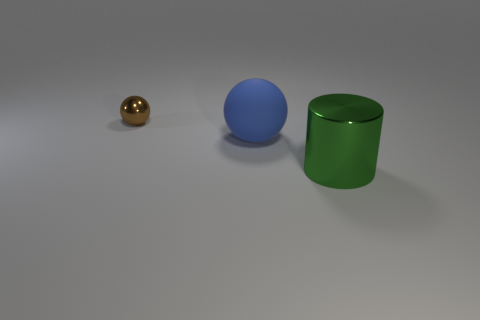Add 3 big cylinders. How many objects exist? 6 Subtract all balls. How many objects are left? 1 Subtract 0 purple spheres. How many objects are left? 3 Subtract all blue rubber objects. Subtract all large cylinders. How many objects are left? 1 Add 2 small objects. How many small objects are left? 3 Add 2 brown metallic objects. How many brown metallic objects exist? 3 